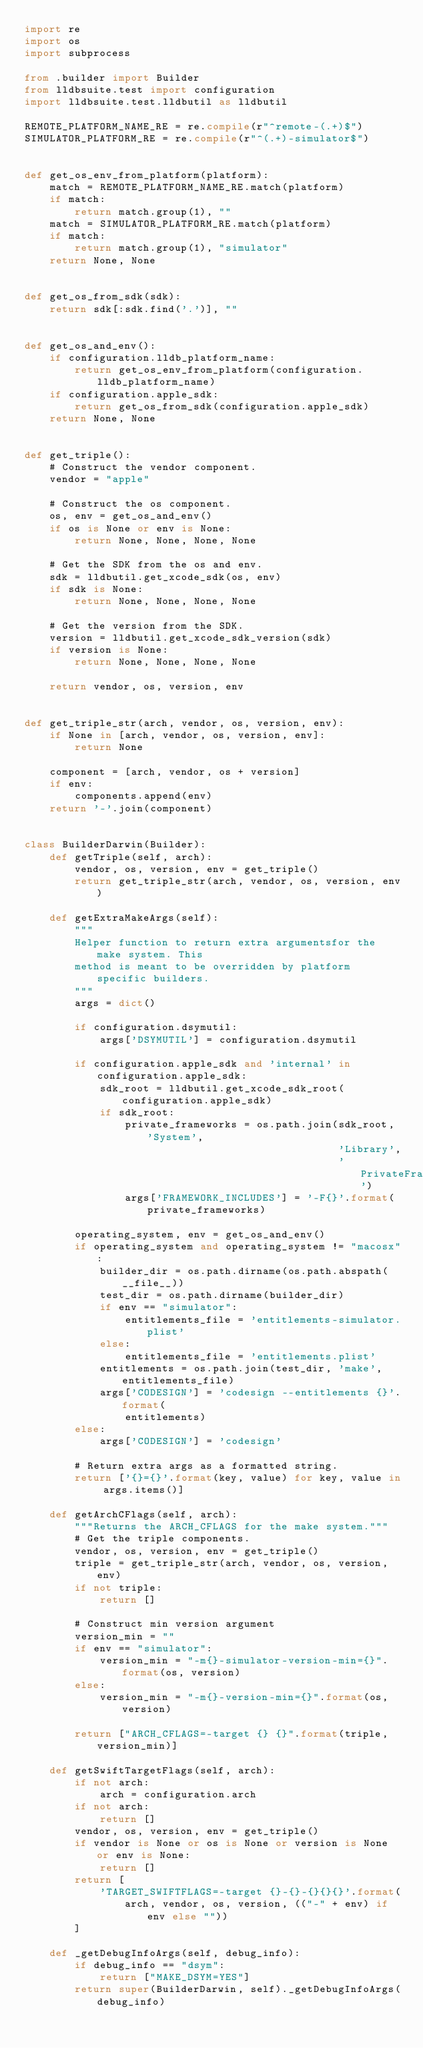Convert code to text. <code><loc_0><loc_0><loc_500><loc_500><_Python_>import re
import os
import subprocess

from .builder import Builder
from lldbsuite.test import configuration
import lldbsuite.test.lldbutil as lldbutil

REMOTE_PLATFORM_NAME_RE = re.compile(r"^remote-(.+)$")
SIMULATOR_PLATFORM_RE = re.compile(r"^(.+)-simulator$")


def get_os_env_from_platform(platform):
    match = REMOTE_PLATFORM_NAME_RE.match(platform)
    if match:
        return match.group(1), ""
    match = SIMULATOR_PLATFORM_RE.match(platform)
    if match:
        return match.group(1), "simulator"
    return None, None


def get_os_from_sdk(sdk):
    return sdk[:sdk.find('.')], ""


def get_os_and_env():
    if configuration.lldb_platform_name:
        return get_os_env_from_platform(configuration.lldb_platform_name)
    if configuration.apple_sdk:
        return get_os_from_sdk(configuration.apple_sdk)
    return None, None


def get_triple():
    # Construct the vendor component.
    vendor = "apple"

    # Construct the os component.
    os, env = get_os_and_env()
    if os is None or env is None:
        return None, None, None, None

    # Get the SDK from the os and env.
    sdk = lldbutil.get_xcode_sdk(os, env)
    if sdk is None:
        return None, None, None, None

    # Get the version from the SDK.
    version = lldbutil.get_xcode_sdk_version(sdk)
    if version is None:
        return None, None, None, None

    return vendor, os, version, env


def get_triple_str(arch, vendor, os, version, env):
    if None in [arch, vendor, os, version, env]:
        return None

    component = [arch, vendor, os + version]
    if env:
        components.append(env)
    return '-'.join(component)


class BuilderDarwin(Builder):
    def getTriple(self, arch):
        vendor, os, version, env = get_triple()
        return get_triple_str(arch, vendor, os, version, env)

    def getExtraMakeArgs(self):
        """
        Helper function to return extra argumentsfor the make system. This
        method is meant to be overridden by platform specific builders.
        """
        args = dict()

        if configuration.dsymutil:
            args['DSYMUTIL'] = configuration.dsymutil

        if configuration.apple_sdk and 'internal' in configuration.apple_sdk:
            sdk_root = lldbutil.get_xcode_sdk_root(configuration.apple_sdk)
            if sdk_root:
                private_frameworks = os.path.join(sdk_root, 'System',
                                                  'Library',
                                                  'PrivateFrameworks')
                args['FRAMEWORK_INCLUDES'] = '-F{}'.format(private_frameworks)

        operating_system, env = get_os_and_env()
        if operating_system and operating_system != "macosx":
            builder_dir = os.path.dirname(os.path.abspath(__file__))
            test_dir = os.path.dirname(builder_dir)
            if env == "simulator":
                entitlements_file = 'entitlements-simulator.plist'
            else:
                entitlements_file = 'entitlements.plist'
            entitlements = os.path.join(test_dir, 'make', entitlements_file)
            args['CODESIGN'] = 'codesign --entitlements {}'.format(
                entitlements)
        else:
            args['CODESIGN'] = 'codesign'

        # Return extra args as a formatted string.
        return ['{}={}'.format(key, value) for key, value in args.items()]

    def getArchCFlags(self, arch):
        """Returns the ARCH_CFLAGS for the make system."""
        # Get the triple components.
        vendor, os, version, env = get_triple()
        triple = get_triple_str(arch, vendor, os, version, env)
        if not triple:
            return []

        # Construct min version argument
        version_min = ""
        if env == "simulator":
            version_min = "-m{}-simulator-version-min={}".format(os, version)
        else:
            version_min = "-m{}-version-min={}".format(os, version)

        return ["ARCH_CFLAGS=-target {} {}".format(triple, version_min)]

    def getSwiftTargetFlags(self, arch):
        if not arch:
            arch = configuration.arch
        if not arch:
            return []
        vendor, os, version, env = get_triple()
        if vendor is None or os is None or version is None or env is None:
            return []
        return [
            'TARGET_SWIFTFLAGS=-target {}-{}-{}{}{}'.format(
                arch, vendor, os, version, (("-" + env) if env else ""))
        ]

    def _getDebugInfoArgs(self, debug_info):
        if debug_info == "dsym":
            return ["MAKE_DSYM=YES"]
        return super(BuilderDarwin, self)._getDebugInfoArgs(debug_info)
</code> 